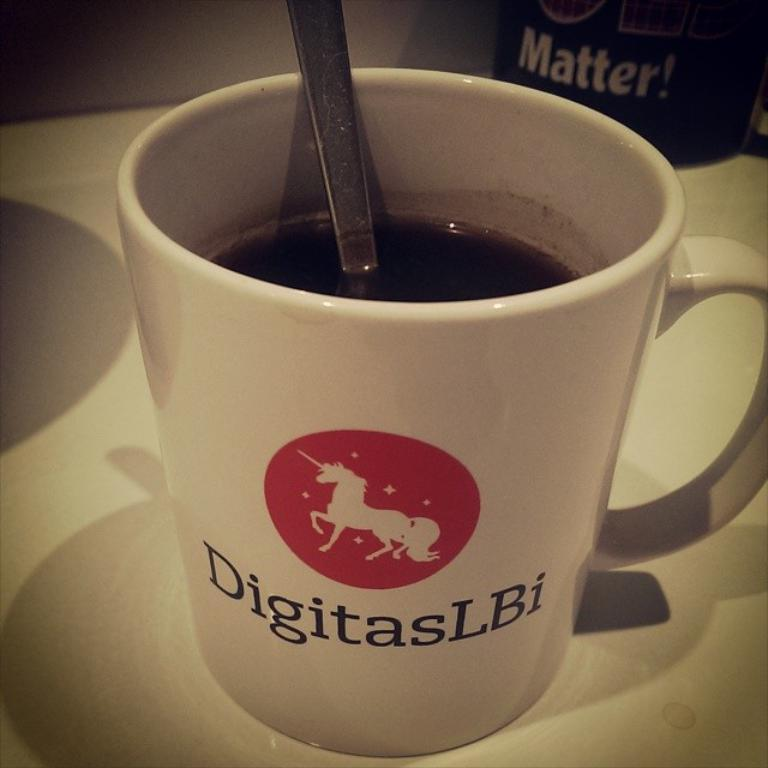<image>
Summarize the visual content of the image. A coffee cup with the image of a unicorn and DigitasLBI on it. 